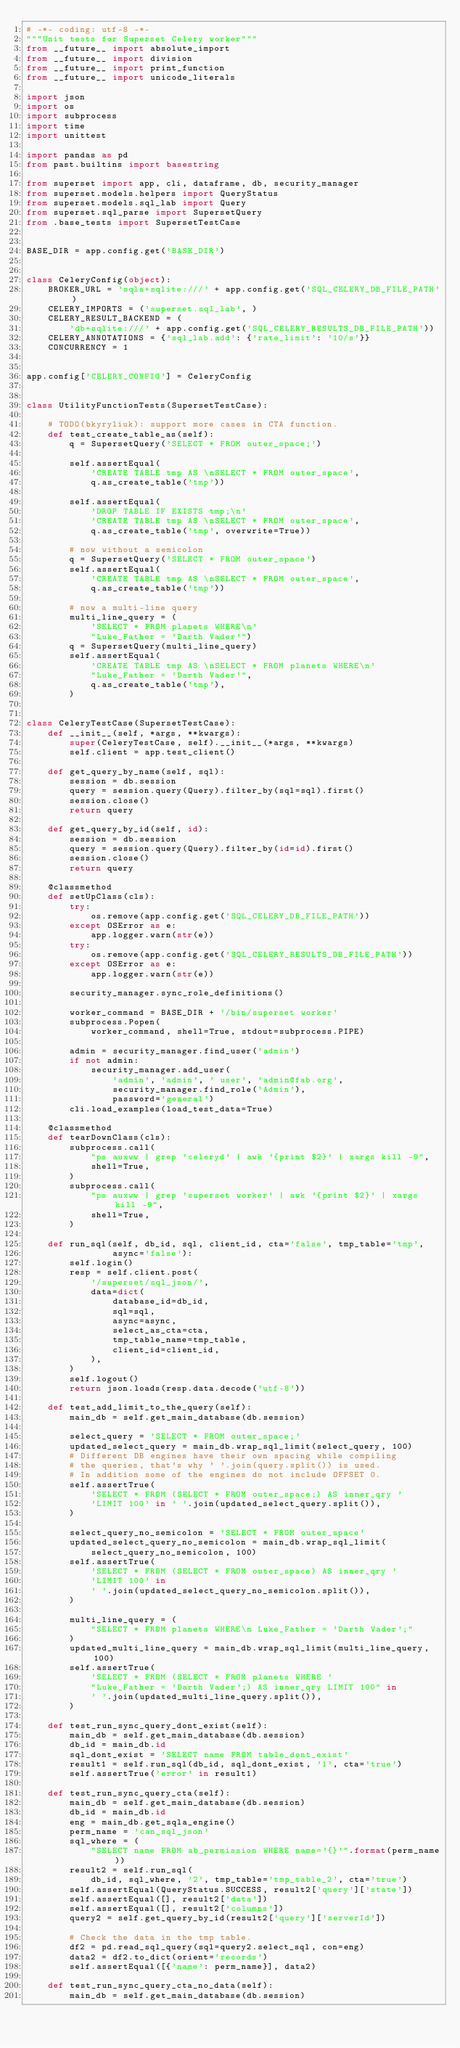<code> <loc_0><loc_0><loc_500><loc_500><_Python_># -*- coding: utf-8 -*-
"""Unit tests for Superset Celery worker"""
from __future__ import absolute_import
from __future__ import division
from __future__ import print_function
from __future__ import unicode_literals

import json
import os
import subprocess
import time
import unittest

import pandas as pd
from past.builtins import basestring

from superset import app, cli, dataframe, db, security_manager
from superset.models.helpers import QueryStatus
from superset.models.sql_lab import Query
from superset.sql_parse import SupersetQuery
from .base_tests import SupersetTestCase


BASE_DIR = app.config.get('BASE_DIR')


class CeleryConfig(object):
    BROKER_URL = 'sqla+sqlite:///' + app.config.get('SQL_CELERY_DB_FILE_PATH')
    CELERY_IMPORTS = ('superset.sql_lab', )
    CELERY_RESULT_BACKEND = (
        'db+sqlite:///' + app.config.get('SQL_CELERY_RESULTS_DB_FILE_PATH'))
    CELERY_ANNOTATIONS = {'sql_lab.add': {'rate_limit': '10/s'}}
    CONCURRENCY = 1


app.config['CELERY_CONFIG'] = CeleryConfig


class UtilityFunctionTests(SupersetTestCase):

    # TODO(bkyryliuk): support more cases in CTA function.
    def test_create_table_as(self):
        q = SupersetQuery('SELECT * FROM outer_space;')

        self.assertEqual(
            'CREATE TABLE tmp AS \nSELECT * FROM outer_space',
            q.as_create_table('tmp'))

        self.assertEqual(
            'DROP TABLE IF EXISTS tmp;\n'
            'CREATE TABLE tmp AS \nSELECT * FROM outer_space',
            q.as_create_table('tmp', overwrite=True))

        # now without a semicolon
        q = SupersetQuery('SELECT * FROM outer_space')
        self.assertEqual(
            'CREATE TABLE tmp AS \nSELECT * FROM outer_space',
            q.as_create_table('tmp'))

        # now a multi-line query
        multi_line_query = (
            'SELECT * FROM planets WHERE\n'
            "Luke_Father = 'Darth Vader'")
        q = SupersetQuery(multi_line_query)
        self.assertEqual(
            'CREATE TABLE tmp AS \nSELECT * FROM planets WHERE\n'
            "Luke_Father = 'Darth Vader'",
            q.as_create_table('tmp'),
        )


class CeleryTestCase(SupersetTestCase):
    def __init__(self, *args, **kwargs):
        super(CeleryTestCase, self).__init__(*args, **kwargs)
        self.client = app.test_client()

    def get_query_by_name(self, sql):
        session = db.session
        query = session.query(Query).filter_by(sql=sql).first()
        session.close()
        return query

    def get_query_by_id(self, id):
        session = db.session
        query = session.query(Query).filter_by(id=id).first()
        session.close()
        return query

    @classmethod
    def setUpClass(cls):
        try:
            os.remove(app.config.get('SQL_CELERY_DB_FILE_PATH'))
        except OSError as e:
            app.logger.warn(str(e))
        try:
            os.remove(app.config.get('SQL_CELERY_RESULTS_DB_FILE_PATH'))
        except OSError as e:
            app.logger.warn(str(e))

        security_manager.sync_role_definitions()

        worker_command = BASE_DIR + '/bin/superset worker'
        subprocess.Popen(
            worker_command, shell=True, stdout=subprocess.PIPE)

        admin = security_manager.find_user('admin')
        if not admin:
            security_manager.add_user(
                'admin', 'admin', ' user', 'admin@fab.org',
                security_manager.find_role('Admin'),
                password='general')
        cli.load_examples(load_test_data=True)

    @classmethod
    def tearDownClass(cls):
        subprocess.call(
            "ps auxww | grep 'celeryd' | awk '{print $2}' | xargs kill -9",
            shell=True,
        )
        subprocess.call(
            "ps auxww | grep 'superset worker' | awk '{print $2}' | xargs kill -9",
            shell=True,
        )

    def run_sql(self, db_id, sql, client_id, cta='false', tmp_table='tmp',
                async='false'):
        self.login()
        resp = self.client.post(
            '/superset/sql_json/',
            data=dict(
                database_id=db_id,
                sql=sql,
                async=async,
                select_as_cta=cta,
                tmp_table_name=tmp_table,
                client_id=client_id,
            ),
        )
        self.logout()
        return json.loads(resp.data.decode('utf-8'))

    def test_add_limit_to_the_query(self):
        main_db = self.get_main_database(db.session)

        select_query = 'SELECT * FROM outer_space;'
        updated_select_query = main_db.wrap_sql_limit(select_query, 100)
        # Different DB engines have their own spacing while compiling
        # the queries, that's why ' '.join(query.split()) is used.
        # In addition some of the engines do not include OFFSET 0.
        self.assertTrue(
            'SELECT * FROM (SELECT * FROM outer_space;) AS inner_qry '
            'LIMIT 100' in ' '.join(updated_select_query.split()),
        )

        select_query_no_semicolon = 'SELECT * FROM outer_space'
        updated_select_query_no_semicolon = main_db.wrap_sql_limit(
            select_query_no_semicolon, 100)
        self.assertTrue(
            'SELECT * FROM (SELECT * FROM outer_space) AS inner_qry '
            'LIMIT 100' in
            ' '.join(updated_select_query_no_semicolon.split()),
        )

        multi_line_query = (
            "SELECT * FROM planets WHERE\n Luke_Father = 'Darth Vader';"
        )
        updated_multi_line_query = main_db.wrap_sql_limit(multi_line_query, 100)
        self.assertTrue(
            'SELECT * FROM (SELECT * FROM planets WHERE '
            "Luke_Father = 'Darth Vader';) AS inner_qry LIMIT 100" in
            ' '.join(updated_multi_line_query.split()),
        )

    def test_run_sync_query_dont_exist(self):
        main_db = self.get_main_database(db.session)
        db_id = main_db.id
        sql_dont_exist = 'SELECT name FROM table_dont_exist'
        result1 = self.run_sql(db_id, sql_dont_exist, '1', cta='true')
        self.assertTrue('error' in result1)

    def test_run_sync_query_cta(self):
        main_db = self.get_main_database(db.session)
        db_id = main_db.id
        eng = main_db.get_sqla_engine()
        perm_name = 'can_sql_json'
        sql_where = (
            "SELECT name FROM ab_permission WHERE name='{}'".format(perm_name))
        result2 = self.run_sql(
            db_id, sql_where, '2', tmp_table='tmp_table_2', cta='true')
        self.assertEqual(QueryStatus.SUCCESS, result2['query']['state'])
        self.assertEqual([], result2['data'])
        self.assertEqual([], result2['columns'])
        query2 = self.get_query_by_id(result2['query']['serverId'])

        # Check the data in the tmp table.
        df2 = pd.read_sql_query(sql=query2.select_sql, con=eng)
        data2 = df2.to_dict(orient='records')
        self.assertEqual([{'name': perm_name}], data2)

    def test_run_sync_query_cta_no_data(self):
        main_db = self.get_main_database(db.session)</code> 